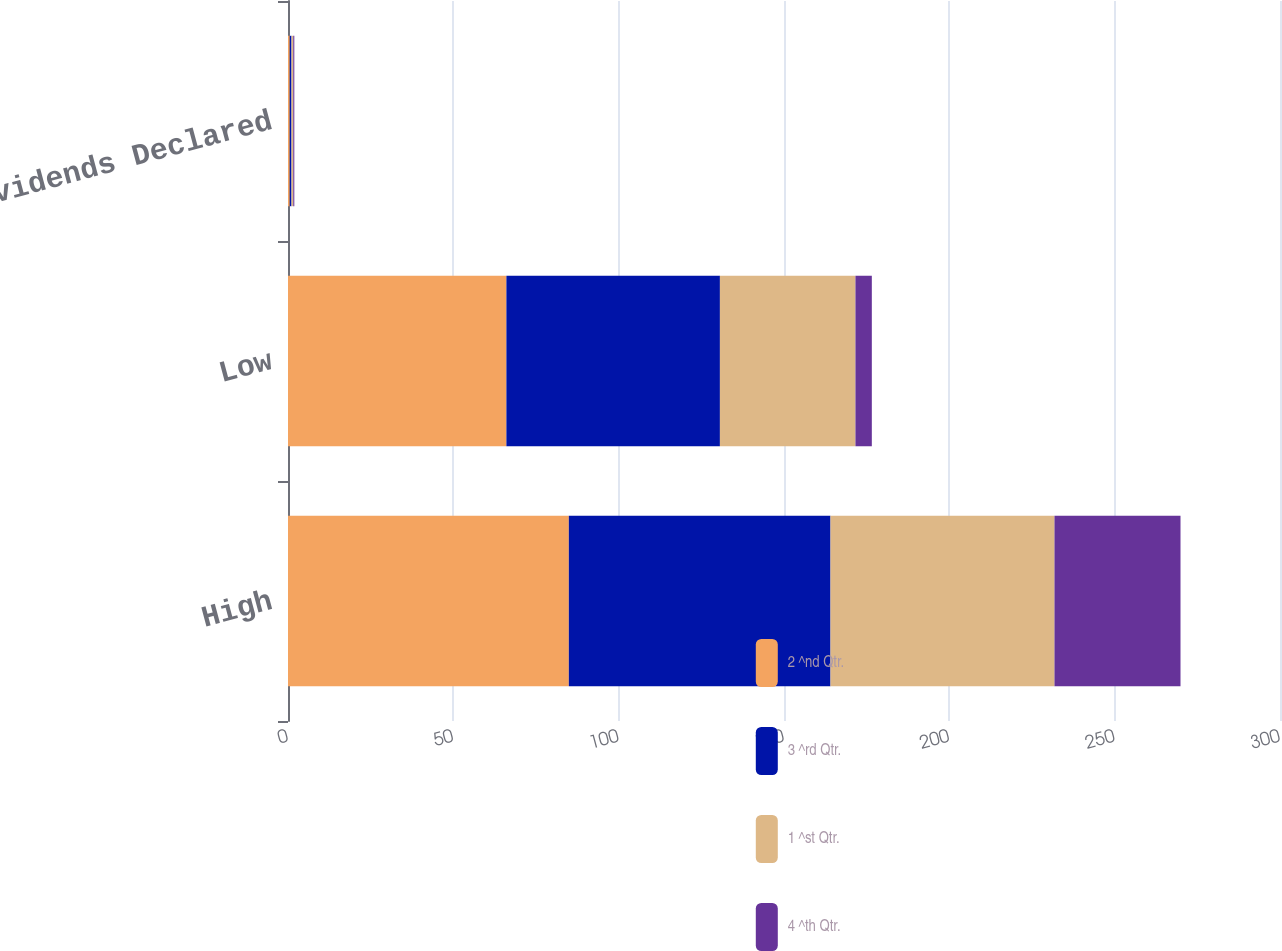Convert chart to OTSL. <chart><loc_0><loc_0><loc_500><loc_500><stacked_bar_chart><ecel><fcel>High<fcel>Low<fcel>Dividends Declared<nl><fcel>2 ^nd Qtr.<fcel>84.93<fcel>66.05<fcel>0.53<nl><fcel>3 ^rd Qtr.<fcel>79.13<fcel>64.57<fcel>0.53<nl><fcel>1 ^st Qtr.<fcel>67.74<fcel>40.99<fcel>0.53<nl><fcel>4 ^th Qtr.<fcel>38.11<fcel>4.95<fcel>0.32<nl></chart> 